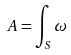Convert formula to latex. <formula><loc_0><loc_0><loc_500><loc_500>A = \int _ { S } \omega</formula> 